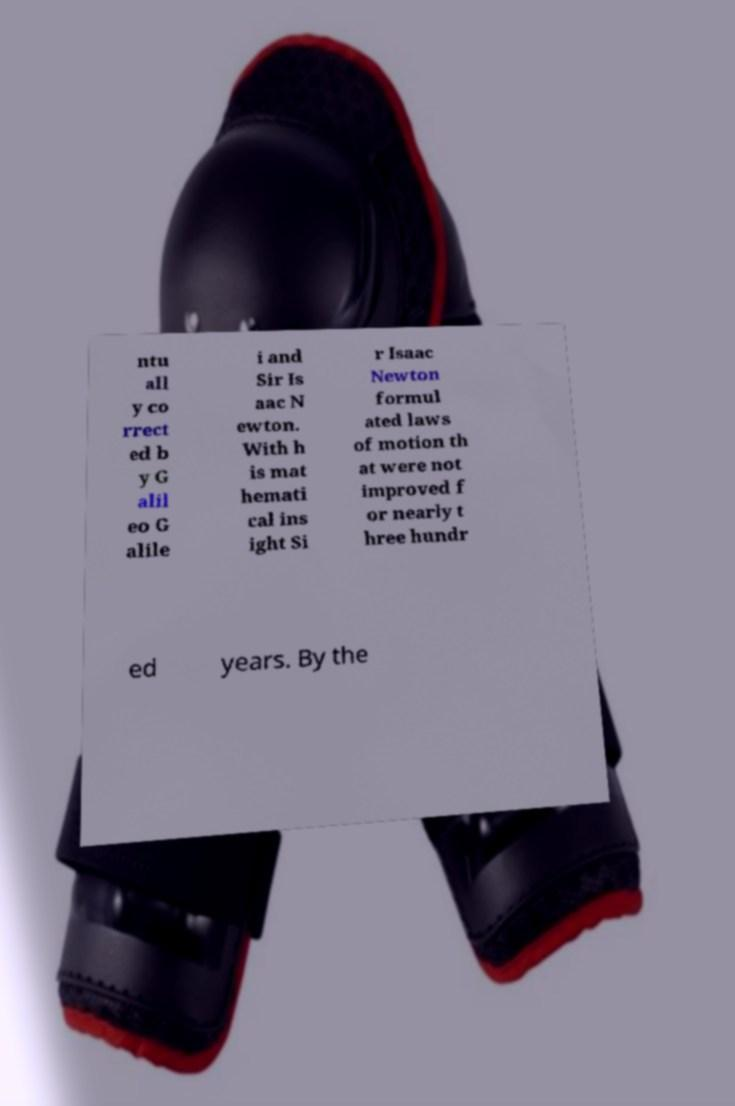Could you extract and type out the text from this image? ntu all y co rrect ed b y G alil eo G alile i and Sir Is aac N ewton. With h is mat hemati cal ins ight Si r Isaac Newton formul ated laws of motion th at were not improved f or nearly t hree hundr ed years. By the 